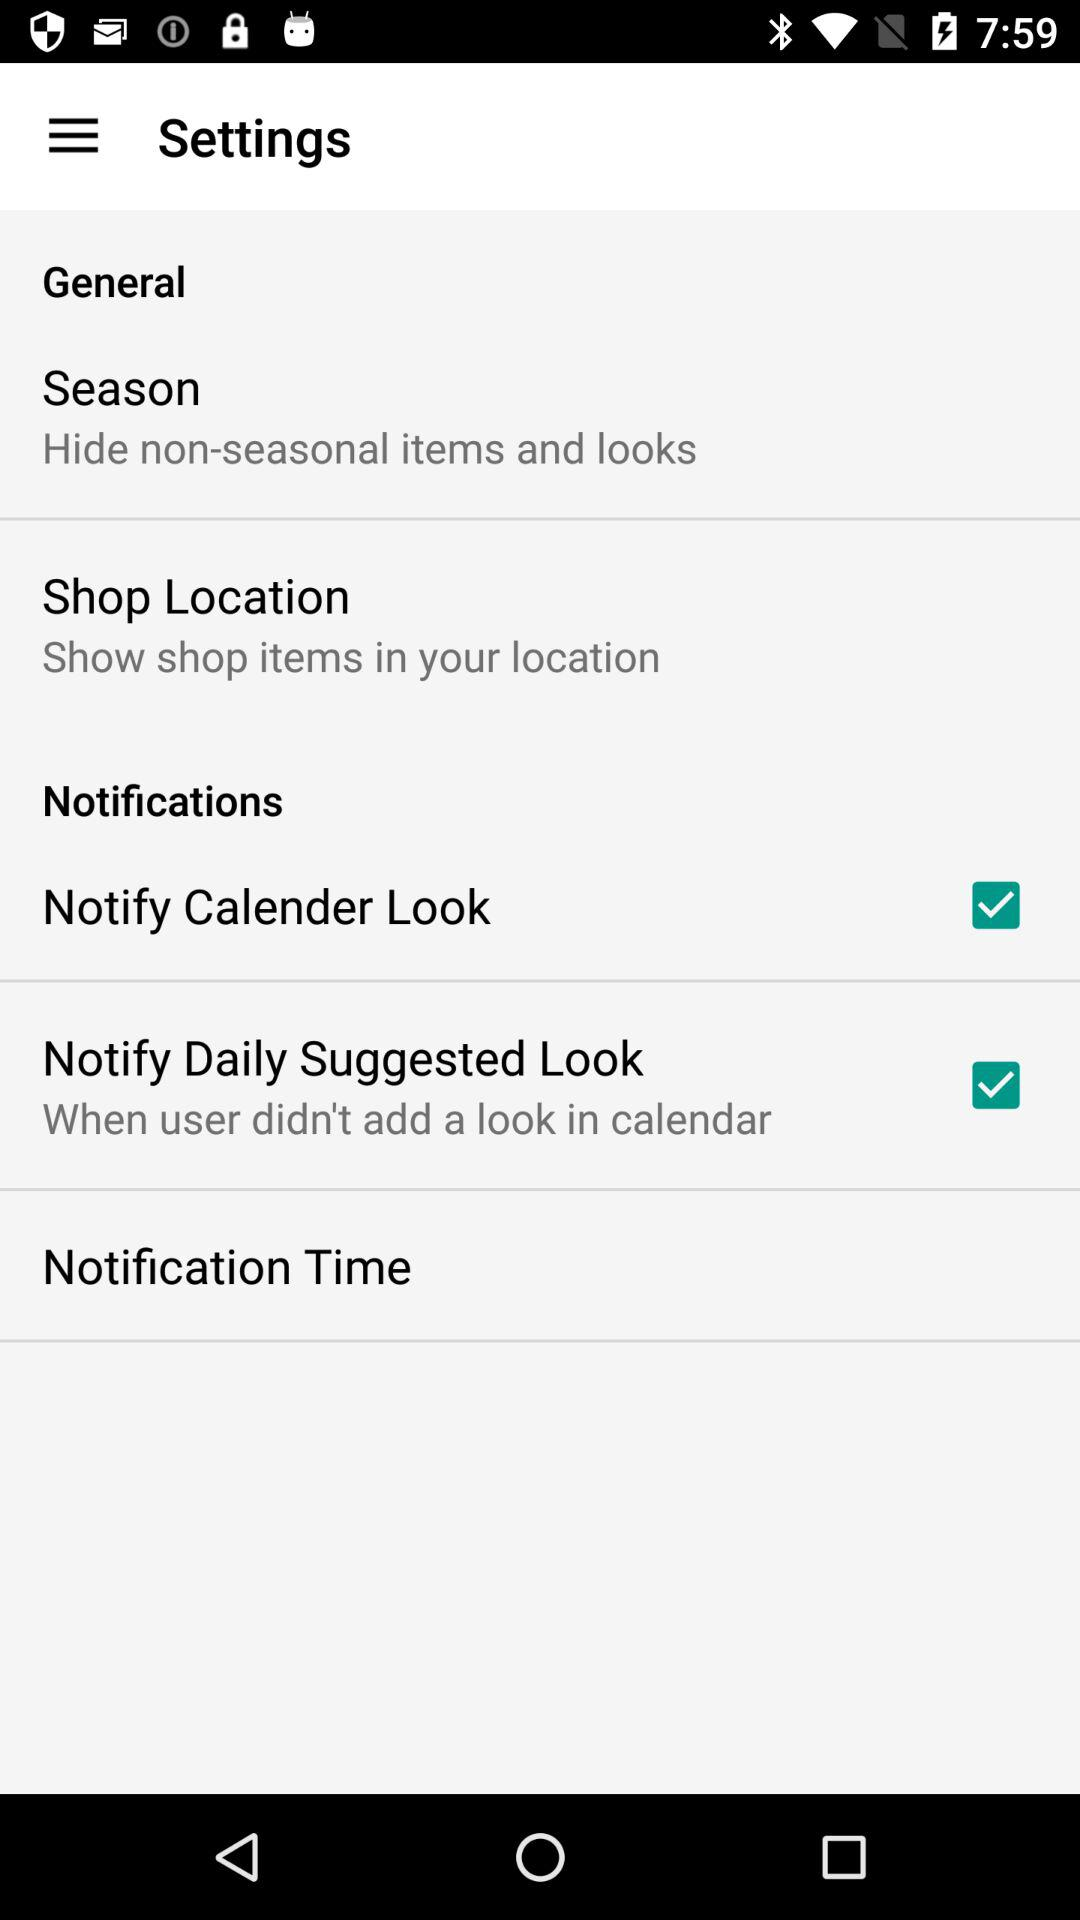Which option is marked as checked? The checked options are "Notify Calender Look" and "Notify Daily Suggested Look". 